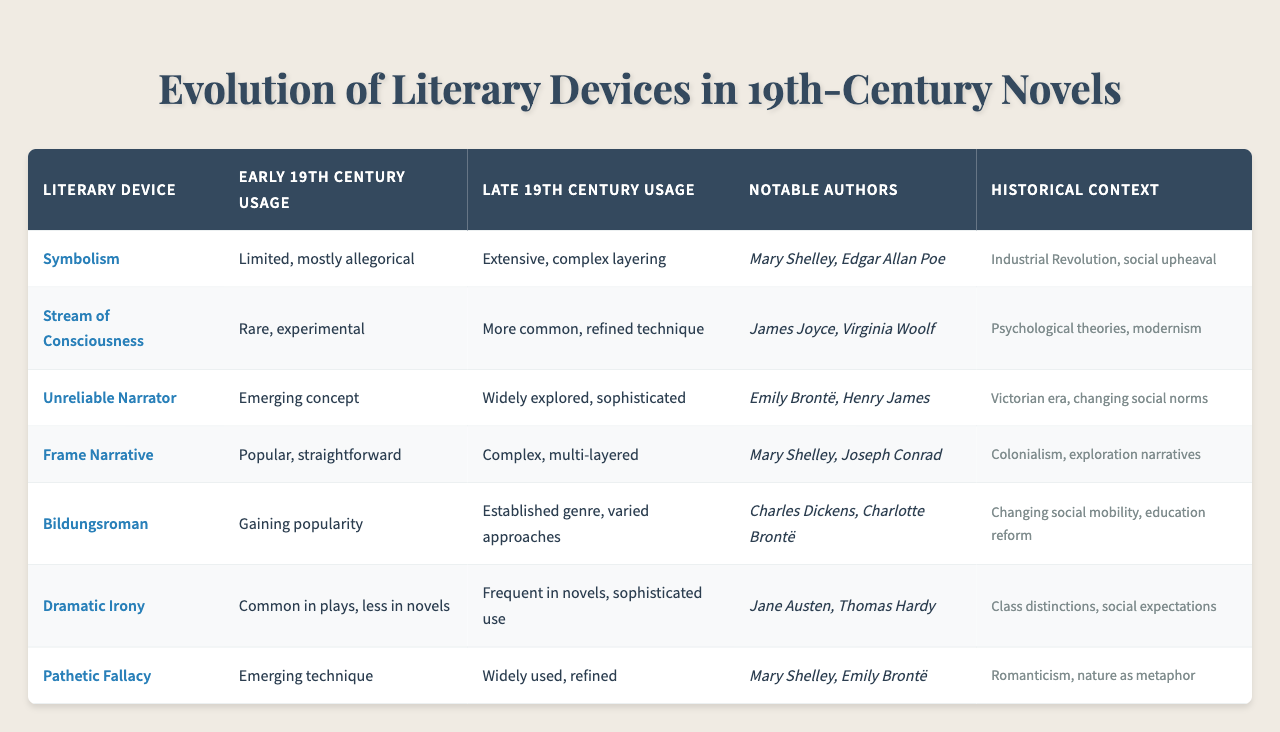What literary device saw an extensive and complex layering in the late 19th century? According to the table, the literary device "Symbolism" had extensive and complex layering in late 19th century usage, as indicated in the respective column.
Answer: Symbolism Which notable authors are associated with the use of the unreliable narrator? The table specifies that Emily Brontë and Henry James are notable authors associated with the "Unreliable Narrator" literary device.
Answer: Emily Brontë, Henry James Did dramatic irony become more frequent in novels by the late 19th century? Yes, the table states that dramatic irony was common in plays during the early 19th century but became frequent in novels with sophisticated use by the late 19th century.
Answer: Yes How did the use of stream of consciousness change from the early to late 19th century? The table shows that it went from rare and experimental in the early 19th century to a more common and refined technique by the late 19th century, highlighting the evolution in its application.
Answer: It became more common and refined What is the historical context for the development of the bildungsroman in the late 19th century? The table connects "Bildungsroman" to changing social mobility and education reform during the late 19th century, illustrating why the genre was being established and varied in its approaches.
Answer: Changing social mobility, education reform Which literary device was primarily attributed to the Romanticism movement in the 19th century? The table attributes "Pathetic Fallacy" as an emerging technique in early 19th century usage and states it was widely used and refined by the late 19th century, relating it to Romanticism's focus on nature.
Answer: Pathetic Fallacy What is the difference in complexity of the frame narrative between the early and late 19th centuries? As per the table, the frame narrative was popular and straightforward in the early 19th century but evolved into a complex, multi-layered structure by the late 19th century, indicating an increase in narrative sophistication.
Answer: It became complex and multi-layered How did the portrayal of symbolism in literature reflect the historical context of the Industrial Revolution? The table mentions that symbolism was limited and mostly allegorical in the early 19th century, evolving to extensive usage by the late 19th century, reflecting the complexities of the Industrial Revolution and social upheaval during that time.
Answer: It reflected complexities of the Industrial Revolution and social upheaval 